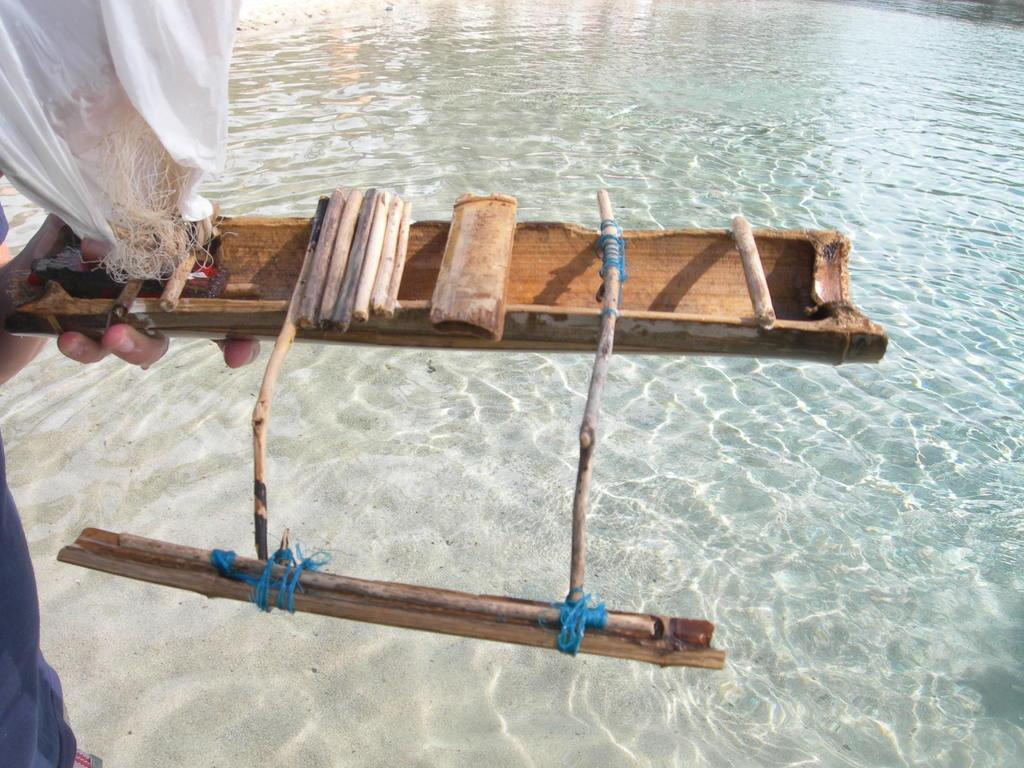Who or what is on the left side of the image? There is a person on the left side of the image. What is the person holding in the image? The person is holding a bamboo stick. What can be seen at the bottom of the image? There is water visible at the bottom of the image. What type of book is the person reading while sitting on the throne in the image? There is no book or throne present in the image; the person is holding a bamboo stick and standing near water. 